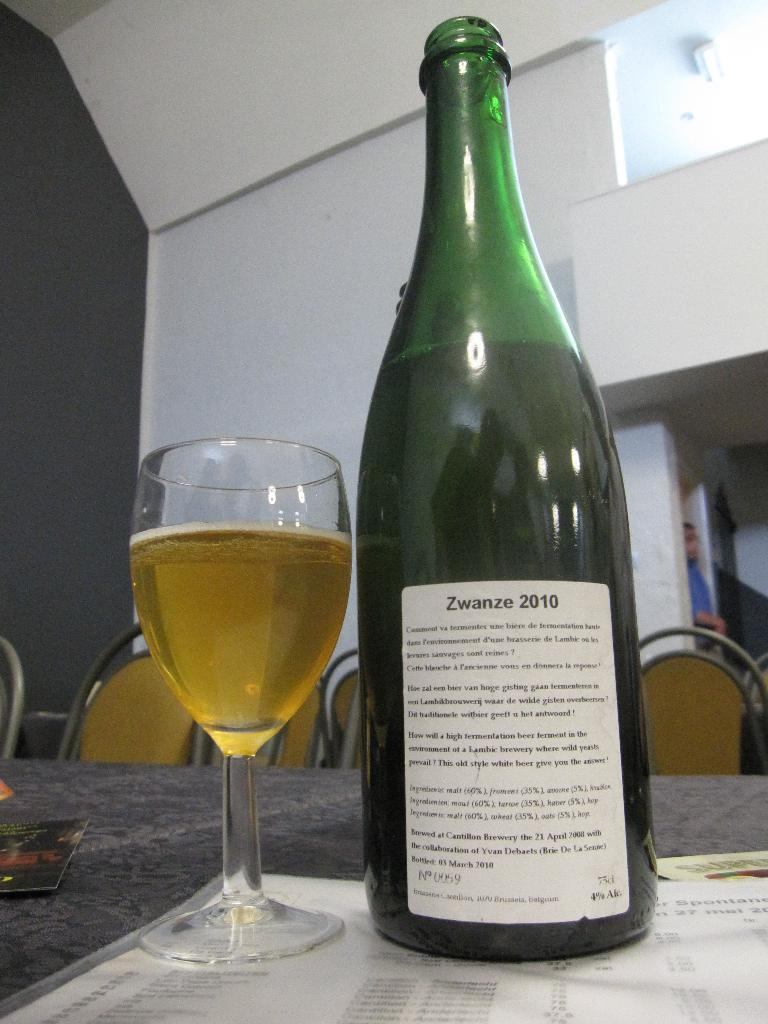What type of container is visible in the image? There is a bottle in the image. What other type of container is present in the image? There is a glass in the image. What type of furniture can be seen in the image? There are chairs in the image. Can you describe the person in the image? There is a person in the image. What is the person in the image trying to crush? There is no indication in the image that the person is trying to crush anything. 